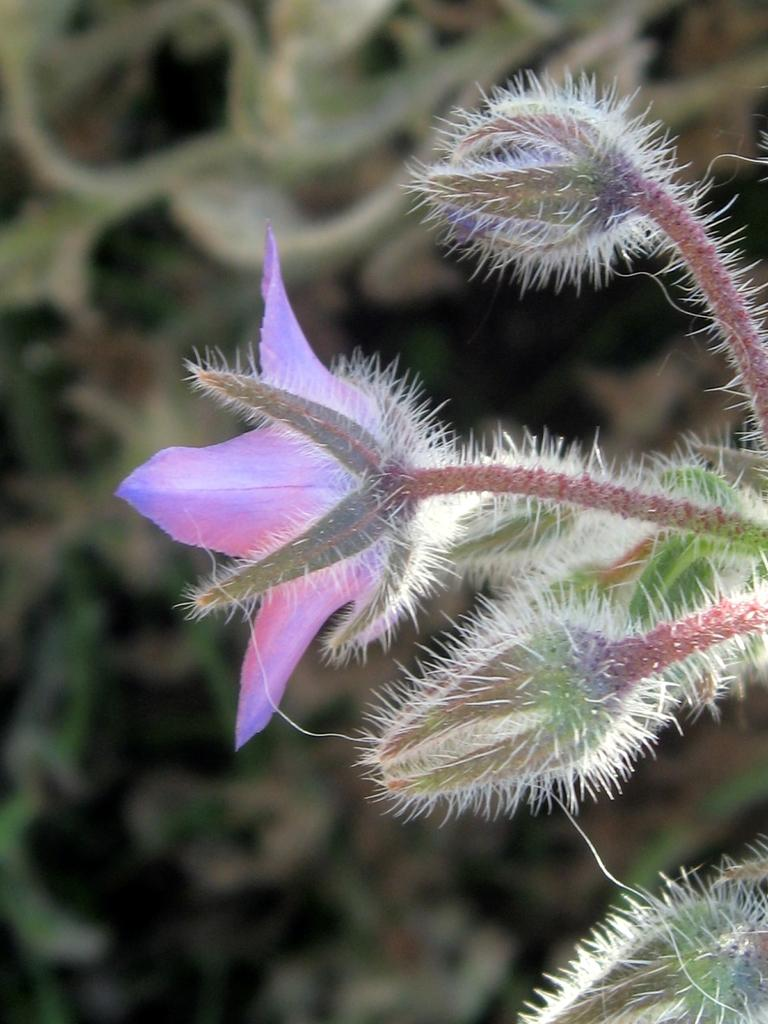What is the main subject of the image? There is a flower in the image. What type of plant does the flower belong to? The flower belongs to a plant. Can you describe the background of the image? The background of the image is blurred. What territory does the partner of the flower occupy in the image? There is no partner of the flower mentioned or visible in the image. 